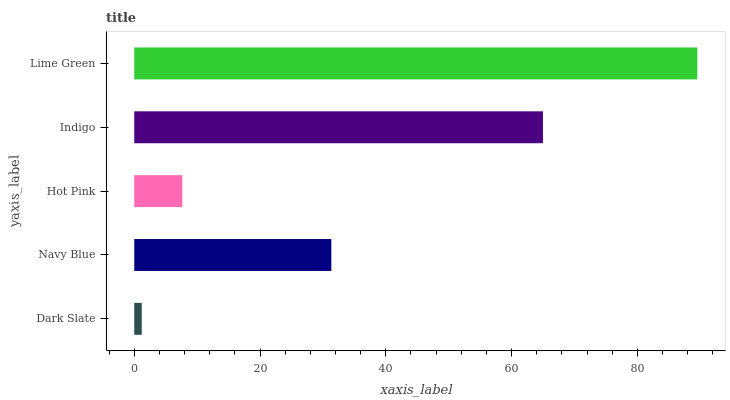Is Dark Slate the minimum?
Answer yes or no. Yes. Is Lime Green the maximum?
Answer yes or no. Yes. Is Navy Blue the minimum?
Answer yes or no. No. Is Navy Blue the maximum?
Answer yes or no. No. Is Navy Blue greater than Dark Slate?
Answer yes or no. Yes. Is Dark Slate less than Navy Blue?
Answer yes or no. Yes. Is Dark Slate greater than Navy Blue?
Answer yes or no. No. Is Navy Blue less than Dark Slate?
Answer yes or no. No. Is Navy Blue the high median?
Answer yes or no. Yes. Is Navy Blue the low median?
Answer yes or no. Yes. Is Hot Pink the high median?
Answer yes or no. No. Is Hot Pink the low median?
Answer yes or no. No. 